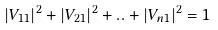Convert formula to latex. <formula><loc_0><loc_0><loc_500><loc_500>| V _ { 1 1 } | ^ { 2 } + | V _ { 2 1 } | ^ { 2 } + . . + | V _ { n 1 } | ^ { 2 } = 1</formula> 